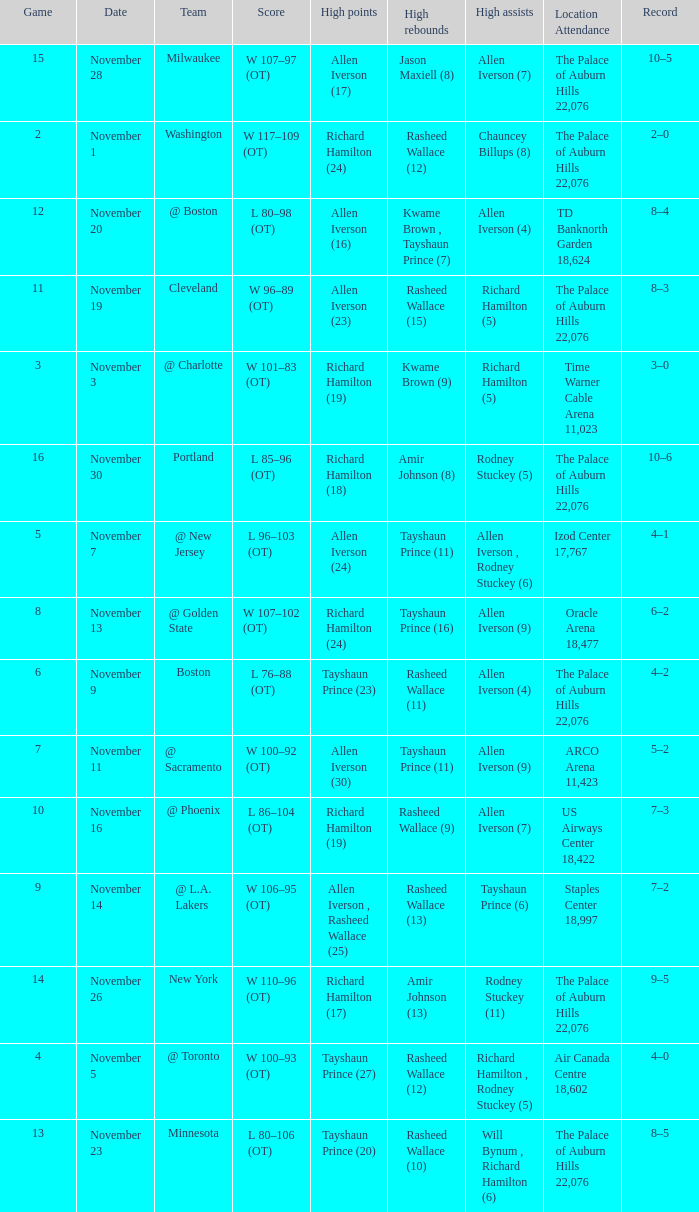What is Location Attendance, when High Points is "Allen Iverson (23)"? The Palace of Auburn Hills 22,076. 